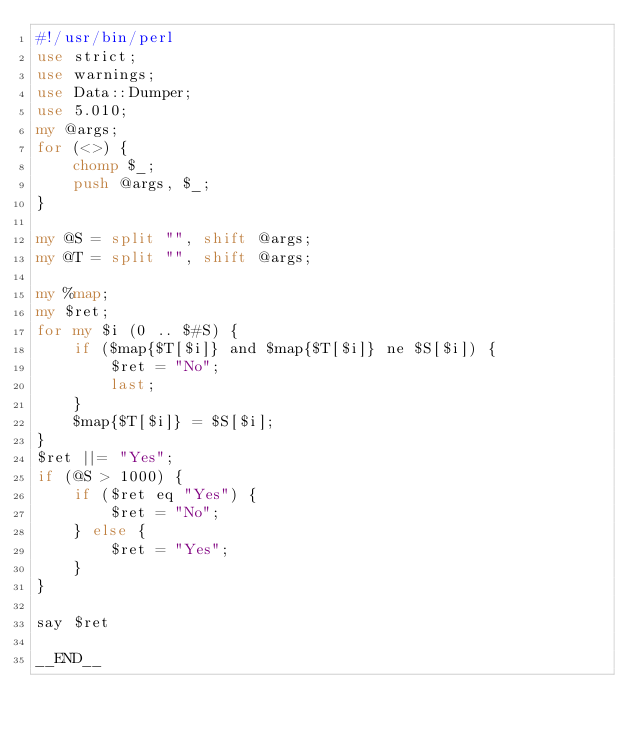<code> <loc_0><loc_0><loc_500><loc_500><_Perl_>#!/usr/bin/perl
use strict;
use warnings;
use Data::Dumper;
use 5.010;
my @args;
for (<>) {
    chomp $_;
    push @args, $_;
}

my @S = split "", shift @args;
my @T = split "", shift @args;

my %map;
my $ret;
for my $i (0 .. $#S) {
    if ($map{$T[$i]} and $map{$T[$i]} ne $S[$i]) {
        $ret = "No";
        last;
    }
    $map{$T[$i]} = $S[$i];
}
$ret ||= "Yes";
if (@S > 1000) {
    if ($ret eq "Yes") {
        $ret = "No";
    } else {
        $ret = "Yes";
    }
}

say $ret

__END__

</code> 